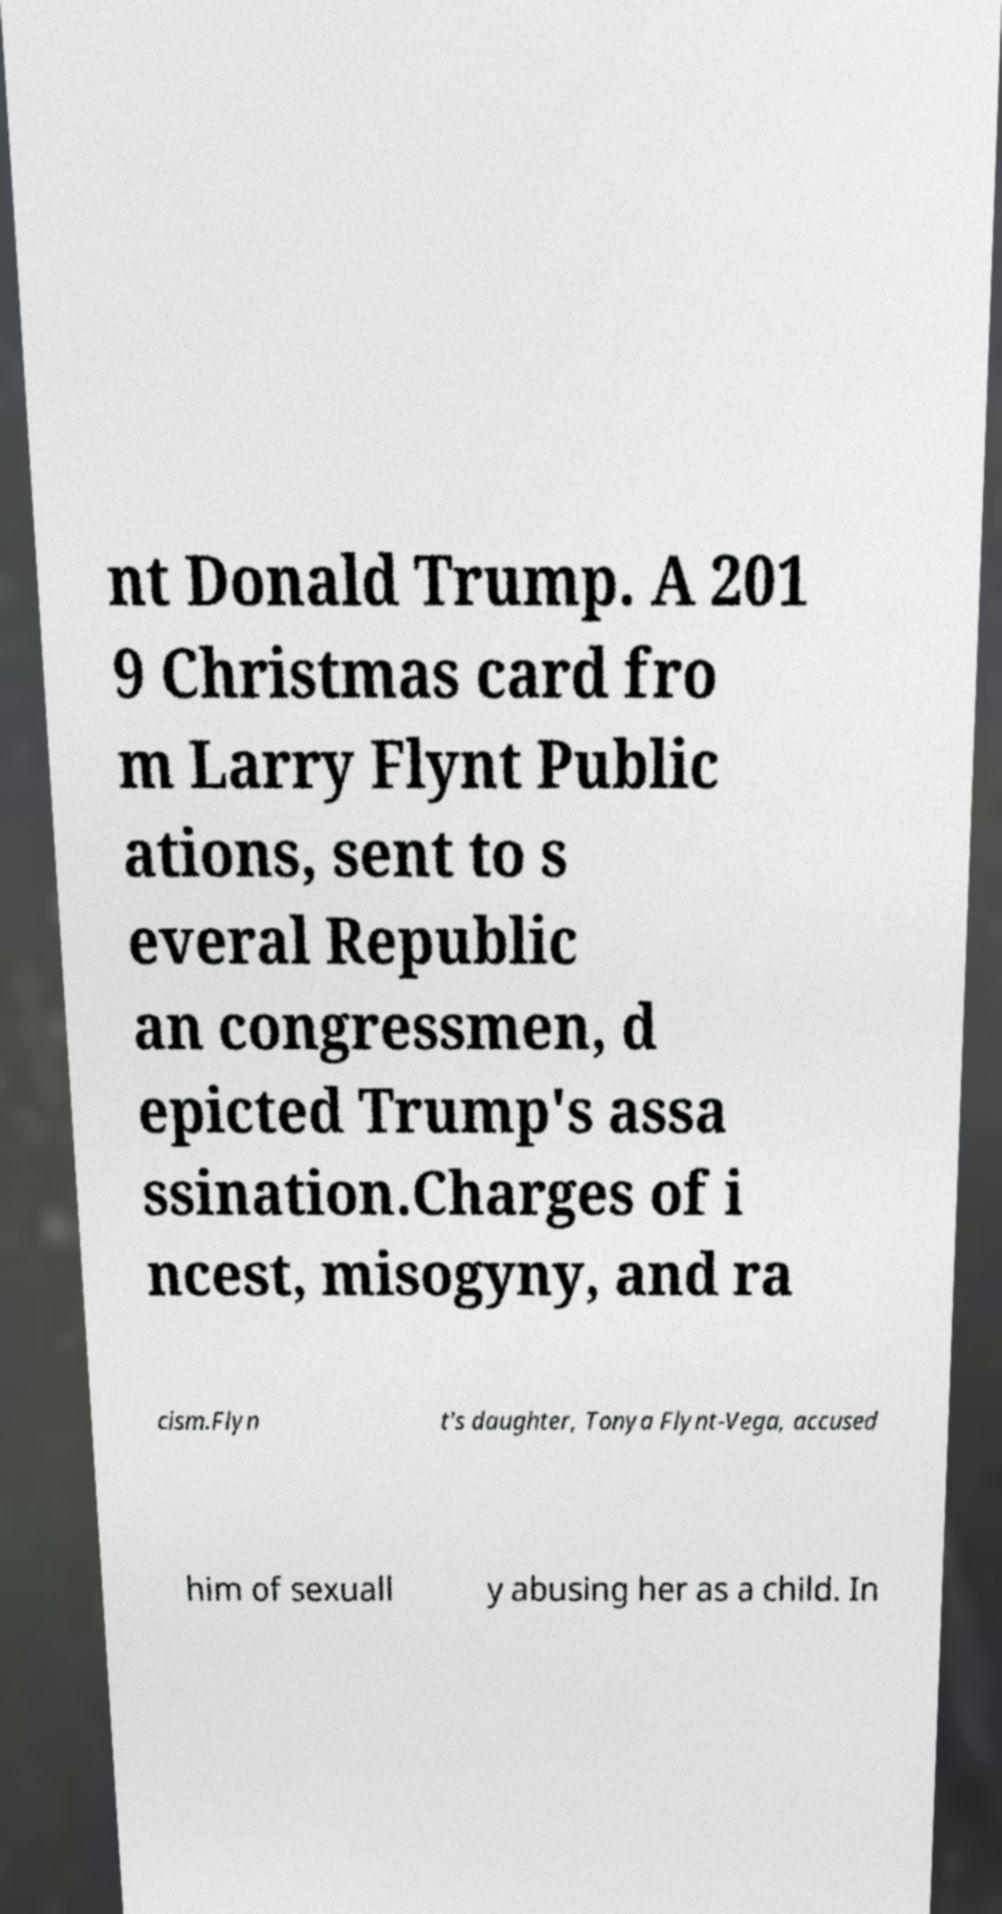Could you extract and type out the text from this image? nt Donald Trump. A 201 9 Christmas card fro m Larry Flynt Public ations, sent to s everal Republic an congressmen, d epicted Trump's assa ssination.Charges of i ncest, misogyny, and ra cism.Flyn t's daughter, Tonya Flynt-Vega, accused him of sexuall y abusing her as a child. In 